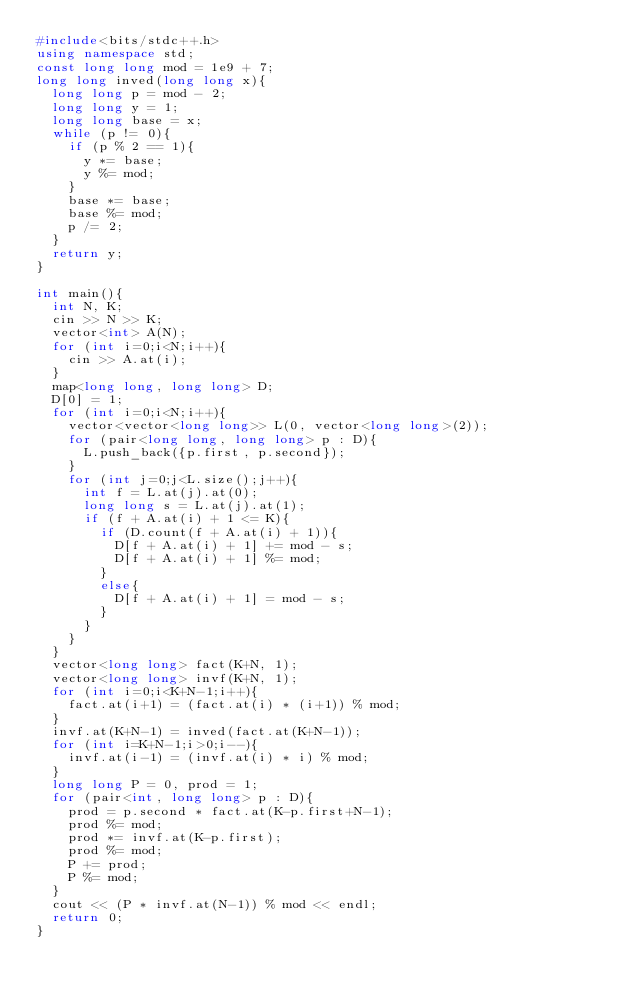<code> <loc_0><loc_0><loc_500><loc_500><_C++_>#include<bits/stdc++.h>
using namespace std;
const long long mod = 1e9 + 7;
long long inved(long long x){
  long long p = mod - 2;
  long long y = 1;
  long long base = x;
  while (p != 0){
    if (p % 2 == 1){
      y *= base;
      y %= mod;
    }
    base *= base;
    base %= mod;
    p /= 2;
  }
  return y;
}

int main(){
  int N, K;
  cin >> N >> K;
  vector<int> A(N);
  for (int i=0;i<N;i++){
    cin >> A.at(i);
  }
  map<long long, long long> D;
  D[0] = 1;
  for (int i=0;i<N;i++){
    vector<vector<long long>> L(0, vector<long long>(2));
    for (pair<long long, long long> p : D){
      L.push_back({p.first, p.second});
    }
    for (int j=0;j<L.size();j++){
      int f = L.at(j).at(0);
      long long s = L.at(j).at(1);
      if (f + A.at(i) + 1 <= K){
        if (D.count(f + A.at(i) + 1)){
          D[f + A.at(i) + 1] += mod - s;
          D[f + A.at(i) + 1] %= mod;
        }
        else{
          D[f + A.at(i) + 1] = mod - s;
        }
      }
    }
  }
  vector<long long> fact(K+N, 1);
  vector<long long> invf(K+N, 1);
  for (int i=0;i<K+N-1;i++){
    fact.at(i+1) = (fact.at(i) * (i+1)) % mod;
  }
  invf.at(K+N-1) = inved(fact.at(K+N-1));
  for (int i=K+N-1;i>0;i--){
    invf.at(i-1) = (invf.at(i) * i) % mod;
  }
  long long P = 0, prod = 1;
  for (pair<int, long long> p : D){
    prod = p.second * fact.at(K-p.first+N-1);
    prod %= mod;
    prod *= invf.at(K-p.first);
    prod %= mod;
    P += prod;
    P %= mod;
  }
  cout << (P * invf.at(N-1)) % mod << endl;
  return 0;
}</code> 